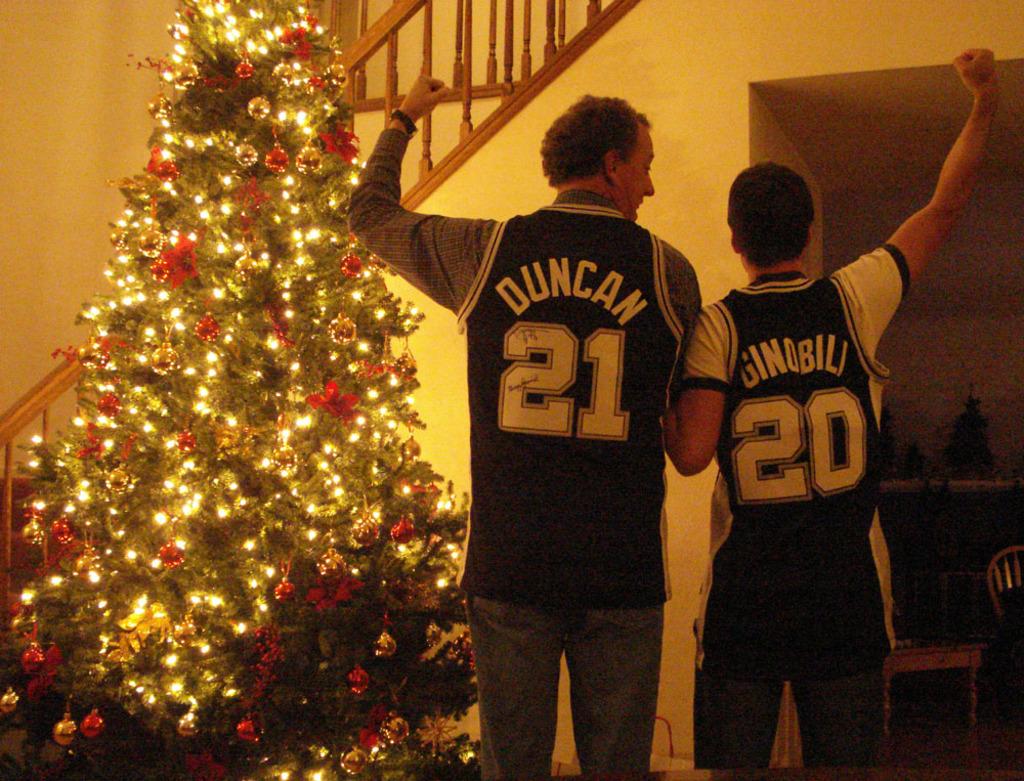What numbers are on these two men's jersey's?
Keep it short and to the point. 21 and 20. What is the name on the jersey on the left?
Your answer should be very brief. Duncan. 